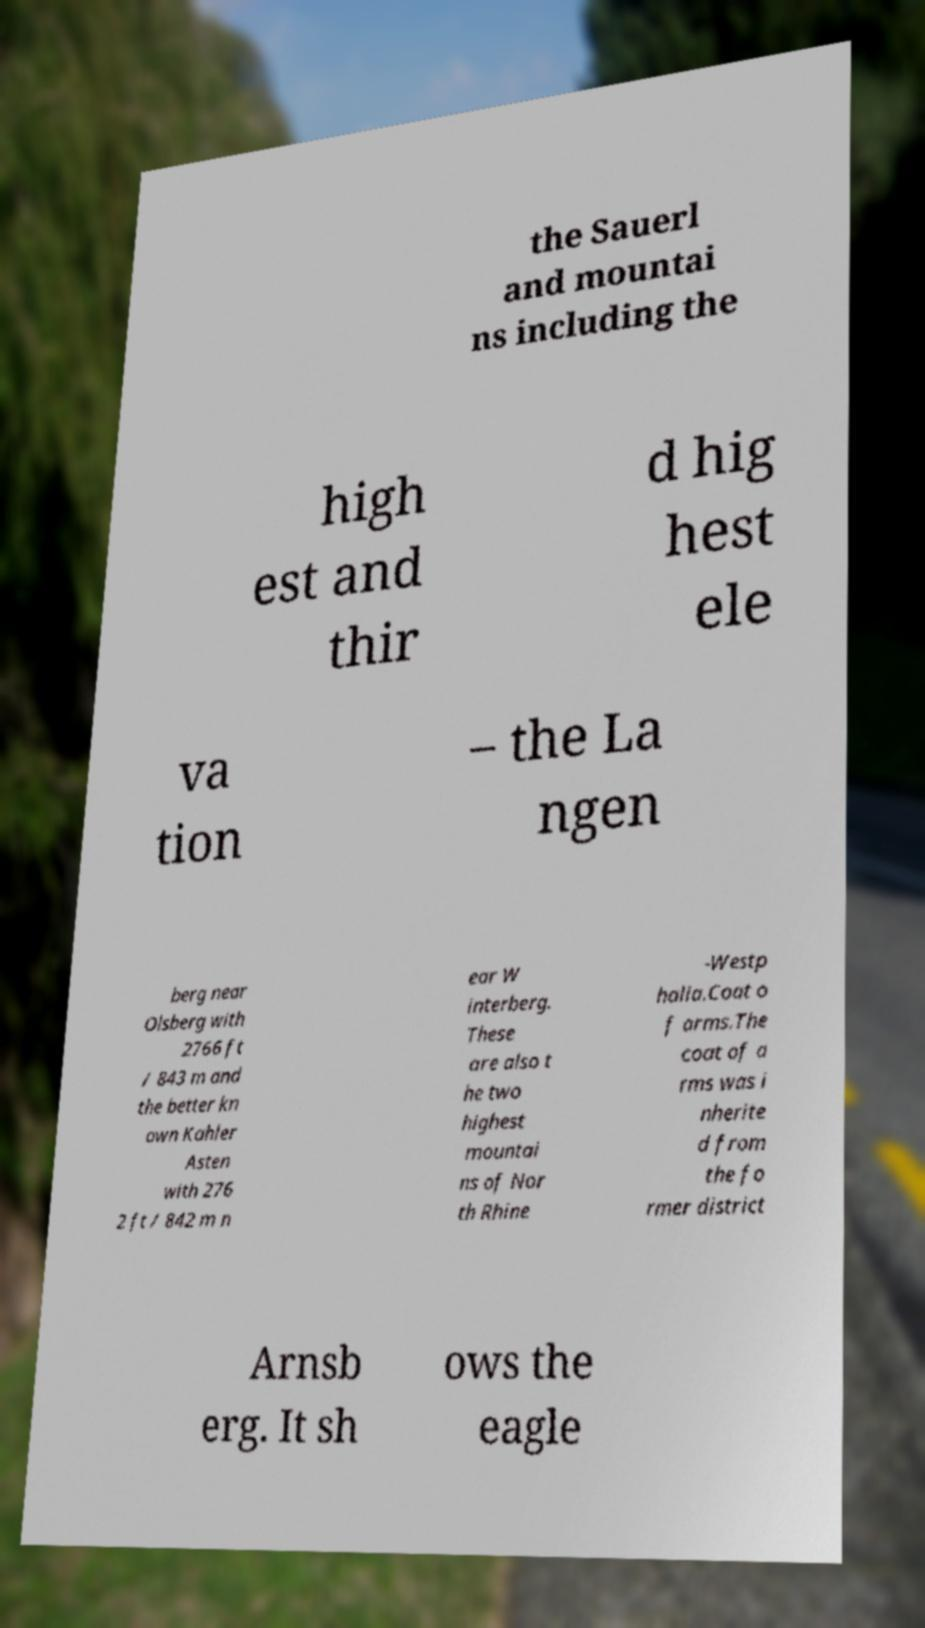Can you accurately transcribe the text from the provided image for me? the Sauerl and mountai ns including the high est and thir d hig hest ele va tion – the La ngen berg near Olsberg with 2766 ft / 843 m and the better kn own Kahler Asten with 276 2 ft / 842 m n ear W interberg. These are also t he two highest mountai ns of Nor th Rhine -Westp halia.Coat o f arms.The coat of a rms was i nherite d from the fo rmer district Arnsb erg. It sh ows the eagle 